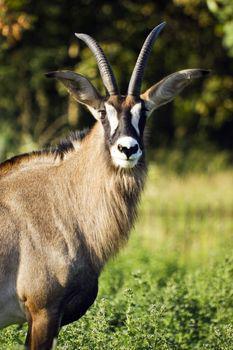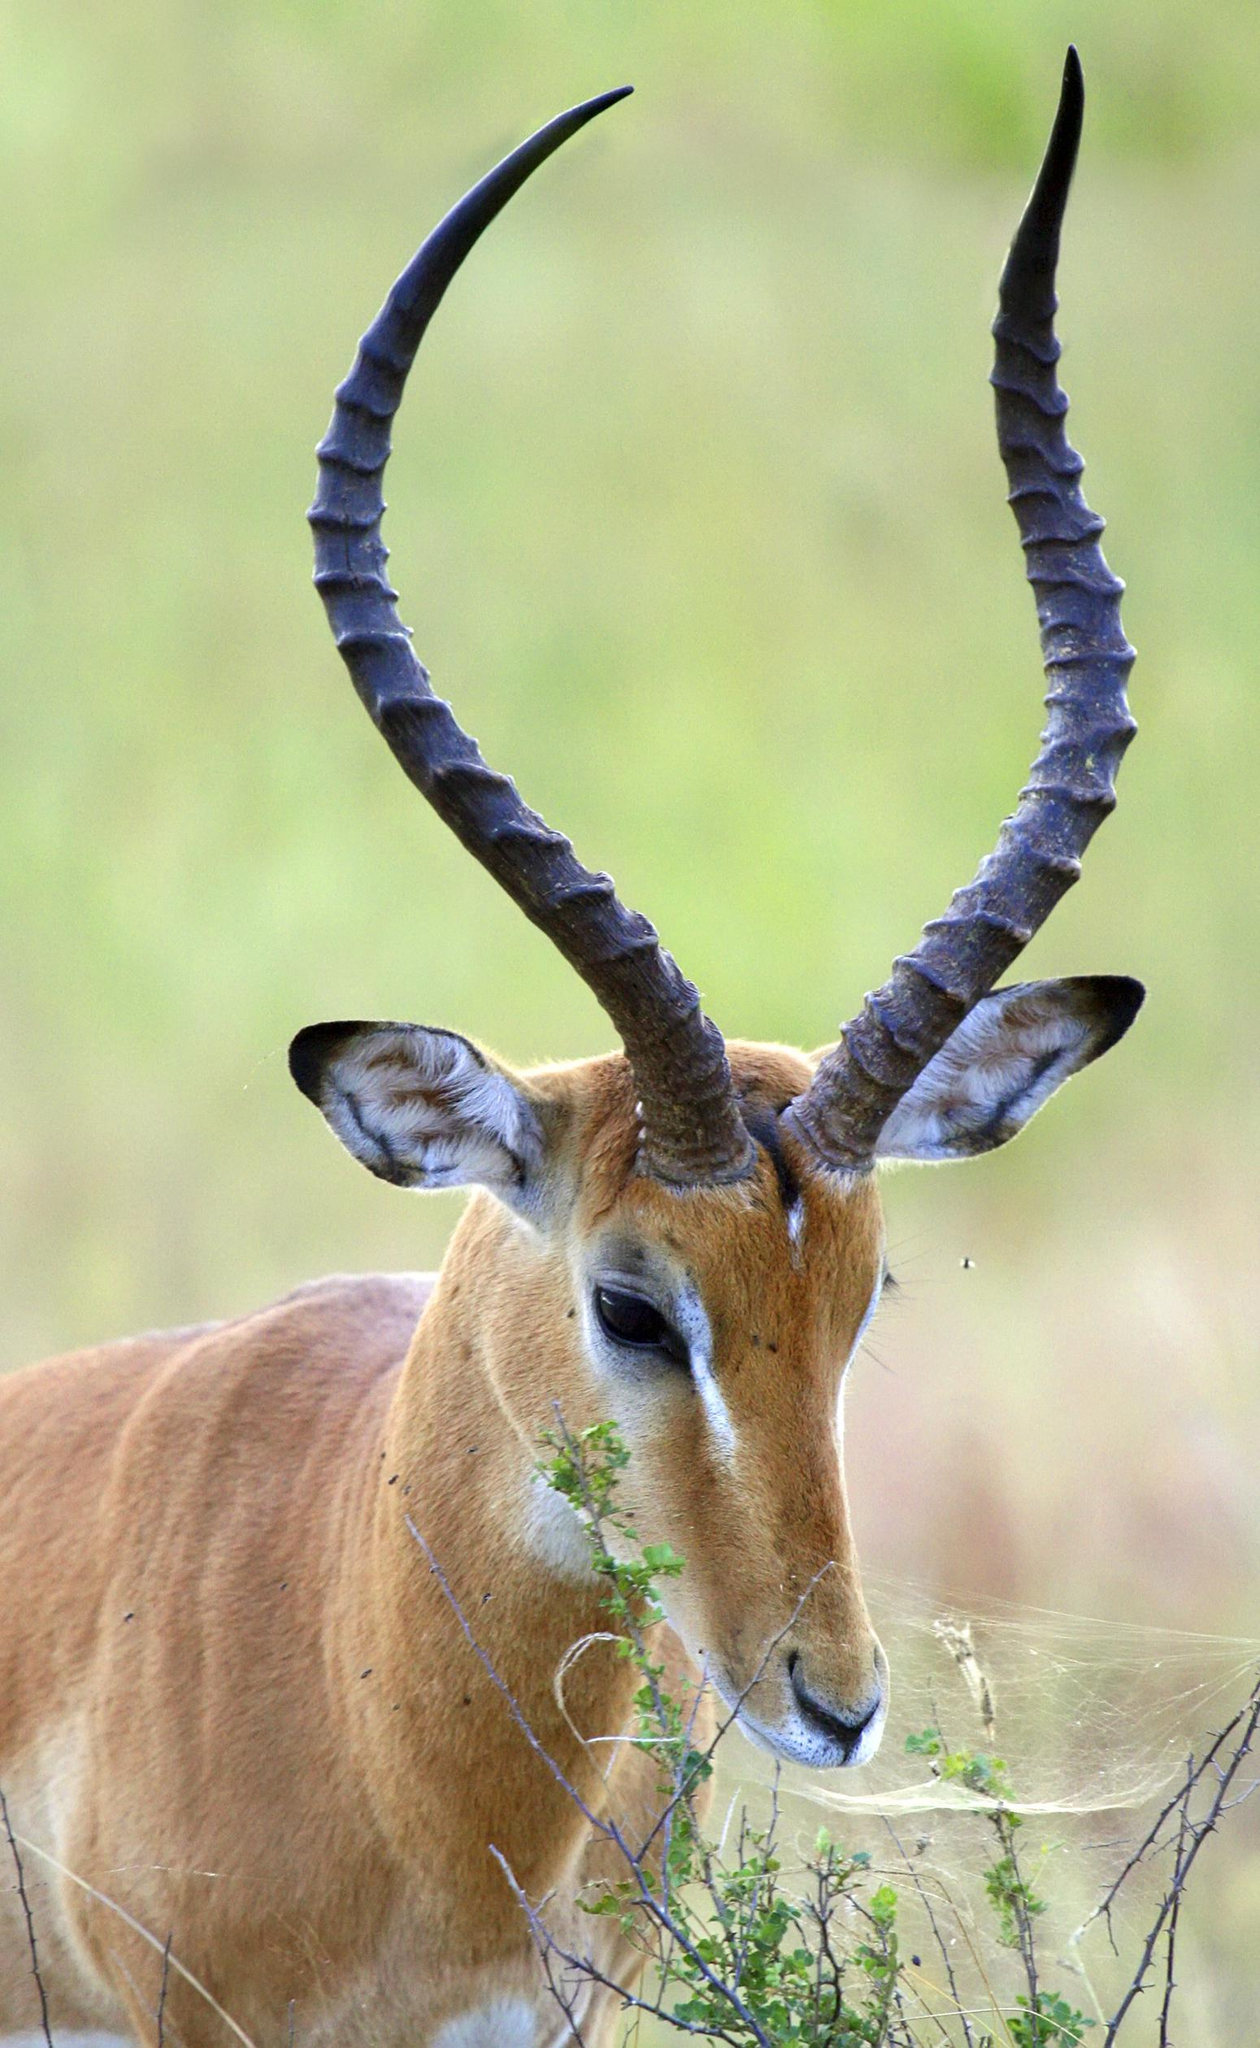The first image is the image on the left, the second image is the image on the right. Analyze the images presented: Is the assertion "The animal in the image on the left is looking into the camera." valid? Answer yes or no. Yes. 